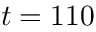Convert formula to latex. <formula><loc_0><loc_0><loc_500><loc_500>t = 1 1 0</formula> 